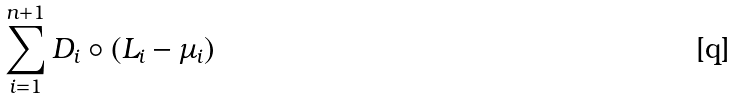<formula> <loc_0><loc_0><loc_500><loc_500>\sum _ { i = 1 } ^ { n + 1 } D _ { i } \circ ( L _ { i } - \mu _ { i } )</formula> 